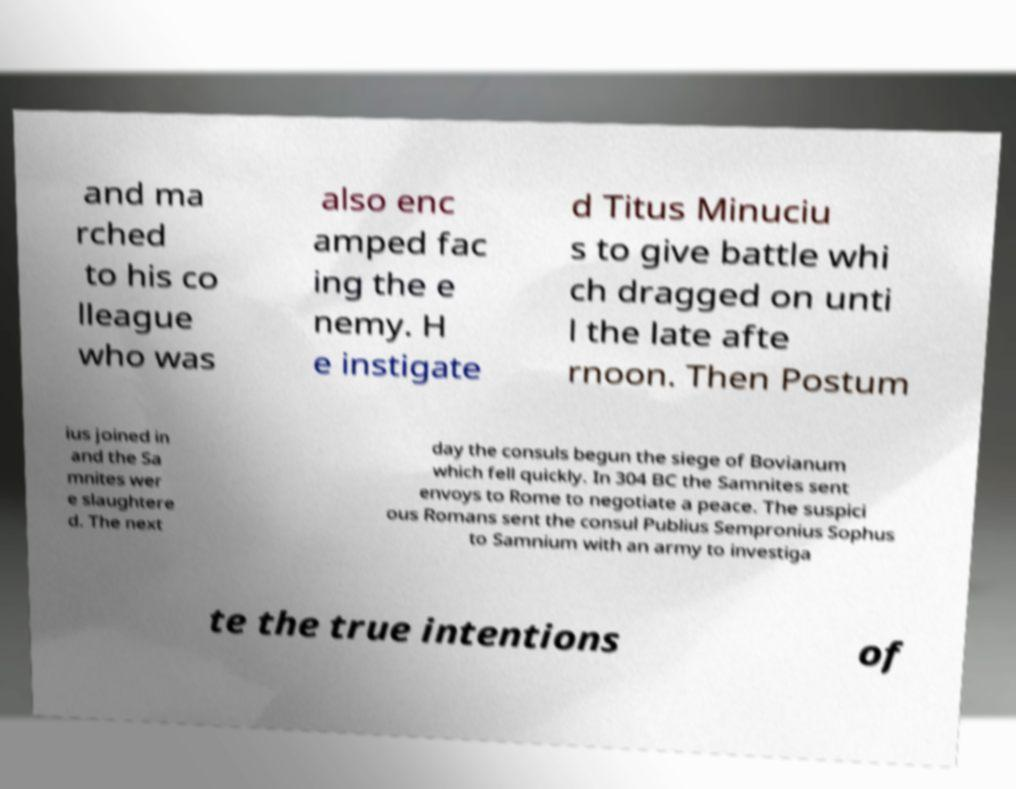What messages or text are displayed in this image? I need them in a readable, typed format. and ma rched to his co lleague who was also enc amped fac ing the e nemy. H e instigate d Titus Minuciu s to give battle whi ch dragged on unti l the late afte rnoon. Then Postum ius joined in and the Sa mnites wer e slaughtere d. The next day the consuls begun the siege of Bovianum which fell quickly. In 304 BC the Samnites sent envoys to Rome to negotiate a peace. The suspici ous Romans sent the consul Publius Sempronius Sophus to Samnium with an army to investiga te the true intentions of 